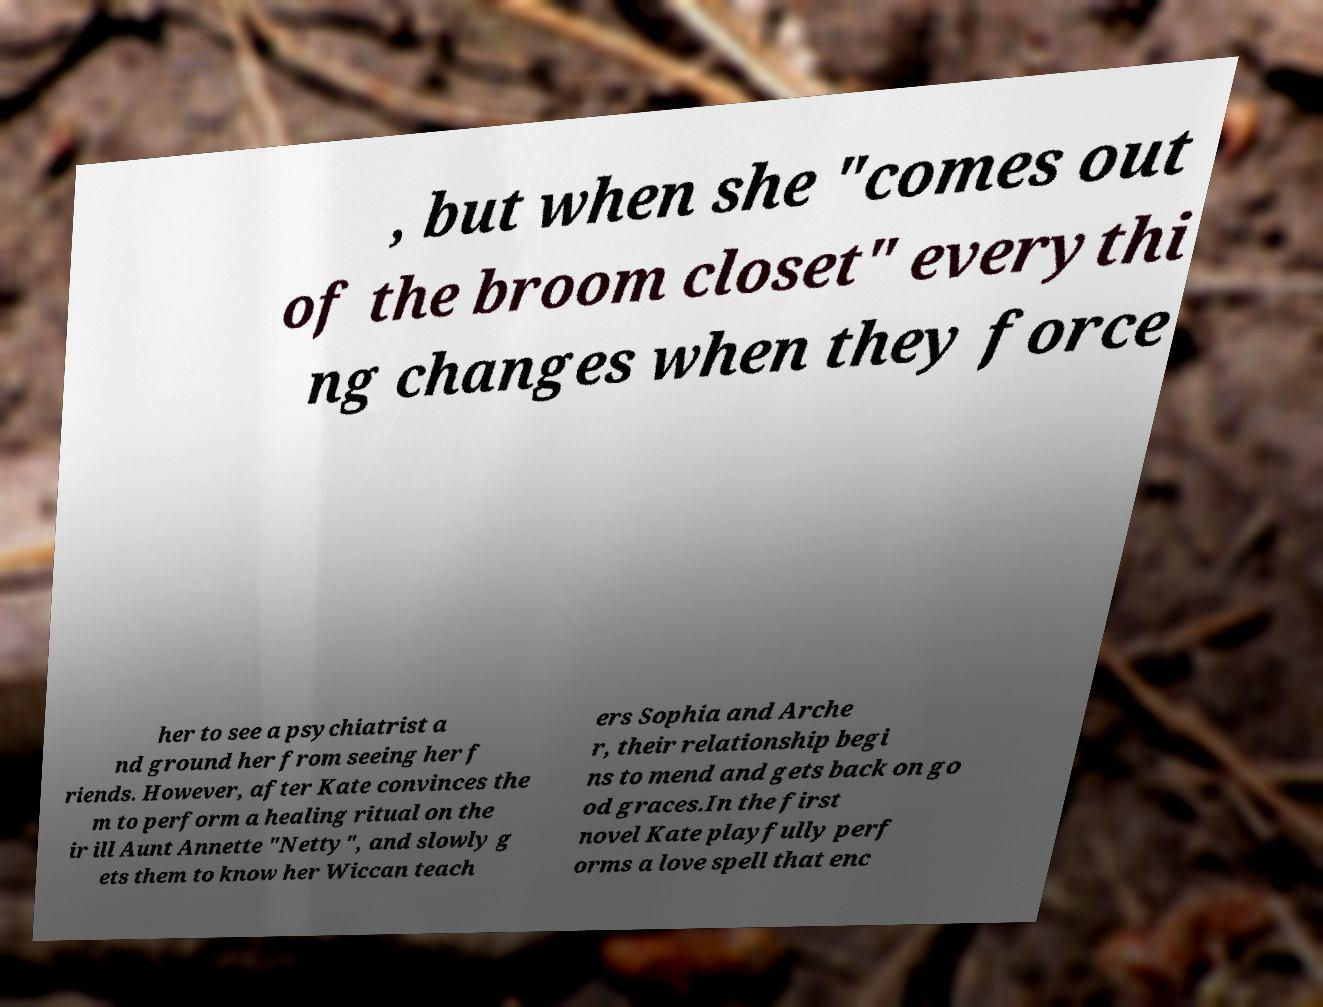Please identify and transcribe the text found in this image. , but when she "comes out of the broom closet" everythi ng changes when they force her to see a psychiatrist a nd ground her from seeing her f riends. However, after Kate convinces the m to perform a healing ritual on the ir ill Aunt Annette "Netty", and slowly g ets them to know her Wiccan teach ers Sophia and Arche r, their relationship begi ns to mend and gets back on go od graces.In the first novel Kate playfully perf orms a love spell that enc 